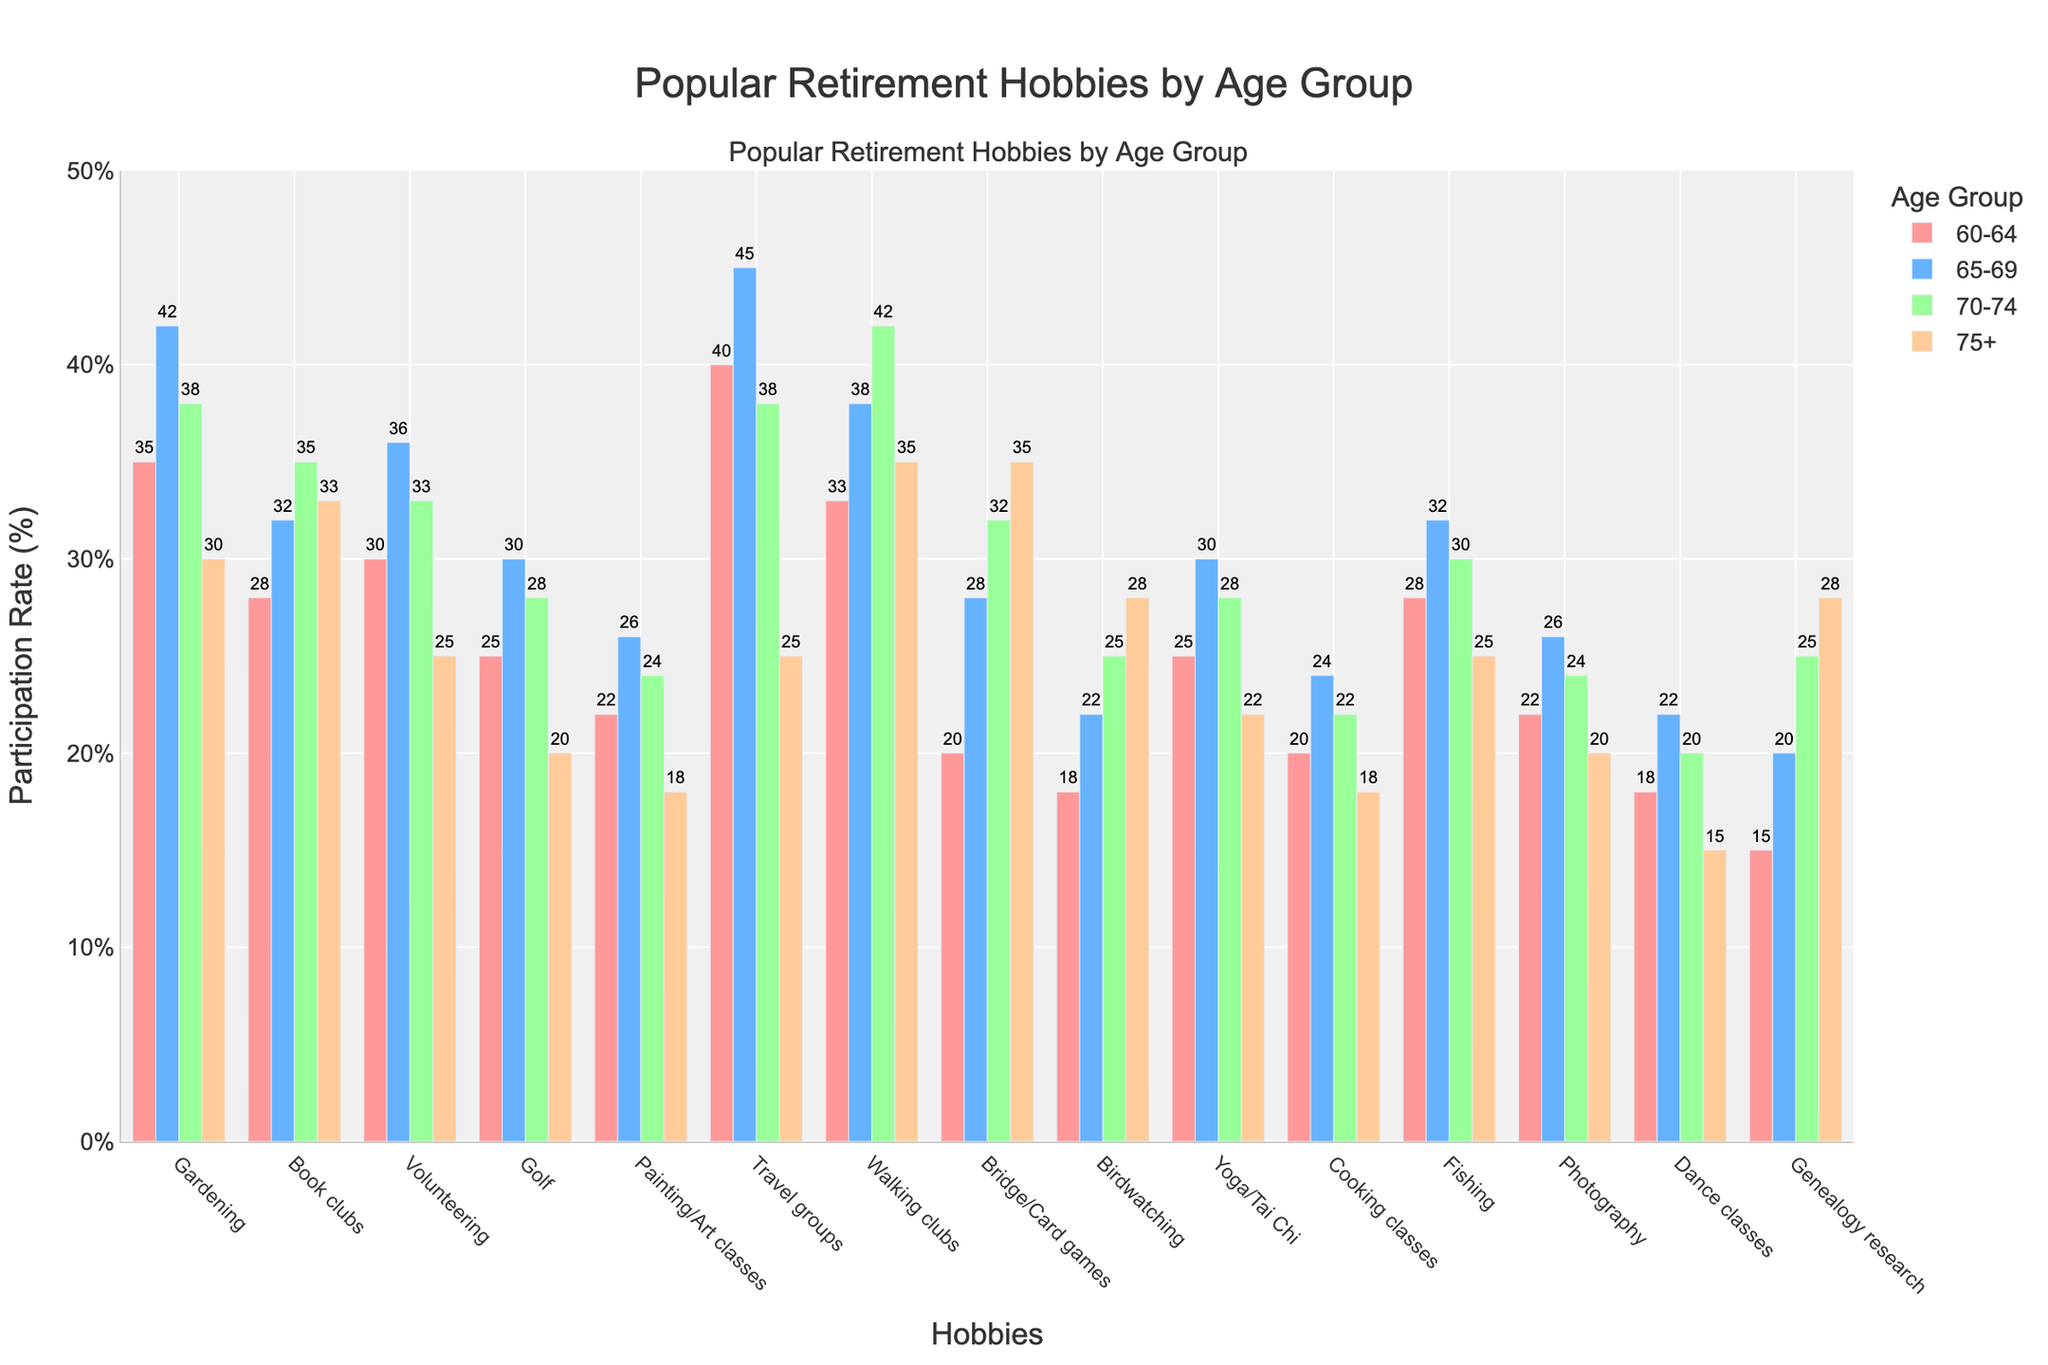What is the participation rate for Walking clubs among those aged 70-74? Look for the bar corresponding to Walking clubs and the age group 70-74. The height of the bar indicates the participation rate, which is 42%.
Answer: 42% Which hobby has the highest participation rate among the 65-69 age group? Look at the bars for the 65-69 age group and compare their heights. The highest bar represents Travel groups with a rate of 45%.
Answer: Travel groups How does the participation rate for Fishing change from the 60-64 age group to the 75+ age group? Look at the bars for Fishing in each age group and observe the heights. The rates are 28%, 32%, 30%, and 25%, respectively, showing a general trend of slight increase and then decrease with age.
Answer: Slight increase then decrease Which hobby shows the largest increase in participation rate between the 60-64 and 65-69 age groups? Compare the bars of each hobby between these two age groups to find the largest height difference. Volunteering shows the largest increase, from 30% to 36%, a change of 6%.
Answer: Volunteering What is the average participation rate for Painting/Art classes across all age groups? Sum the participation rates for Painting/Art classes across all age groups: 22 + 26 + 24 + 18 = 90. Then, divide by the number of age groups, which is 4. The calculation is 90/4 = 22.5%.
Answer: 22.5% For the 75+ age group, which hobby has the lowest participation rate? Look at the bars for the 75+ age group and find the shortest bar. The shortest bar is for Dance classes, with a rate of 15%.
Answer: Dance classes Is the participation rate for Yoga/Tai Chi among the 70-74 age group higher than that for Golf among the same age group? Compare the heights of the bars for Yoga/Tai Chi and Golf for the 70-74 age group. Yoga/Tai Chi stands at 28%, while Golf is at 28%, indicating they are equal.
Answer: Equal Which hobby's participation rate declines the most from the 65-69 to 75+ age groups? Find the difference in heights for each hobby between these age groups and look for the largest difference. Travel groups decline from 45% to 25%, a drop of 20%.
Answer: Travel groups What is the total participation rate for Bridge/Card games across all age groups? Sum the participation rates for Bridge/Card games across all age groups: 20 + 28 + 32 + 35 = 115%.
Answer: 115% In which age group does Birdwatching have the highest participation rate? Look at the bars for Birdwatching across all age groups and identify the tallest bar. The highest participation rate is in the 75+ age group at 28%.
Answer: 75+ 